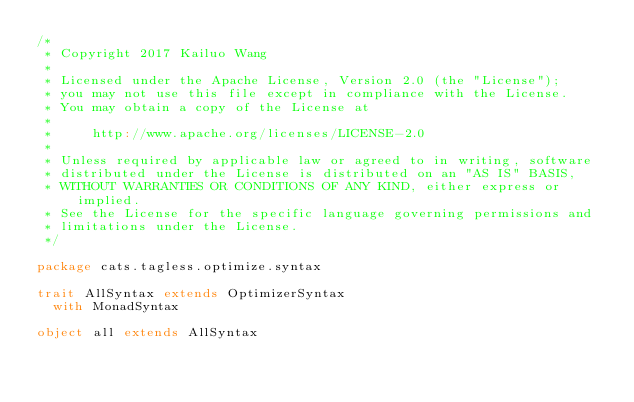Convert code to text. <code><loc_0><loc_0><loc_500><loc_500><_Scala_>/*
 * Copyright 2017 Kailuo Wang
 *
 * Licensed under the Apache License, Version 2.0 (the "License");
 * you may not use this file except in compliance with the License.
 * You may obtain a copy of the License at
 *
 *     http://www.apache.org/licenses/LICENSE-2.0
 *
 * Unless required by applicable law or agreed to in writing, software
 * distributed under the License is distributed on an "AS IS" BASIS,
 * WITHOUT WARRANTIES OR CONDITIONS OF ANY KIND, either express or implied.
 * See the License for the specific language governing permissions and
 * limitations under the License.
 */

package cats.tagless.optimize.syntax

trait AllSyntax extends OptimizerSyntax
  with MonadSyntax

object all extends AllSyntax
</code> 